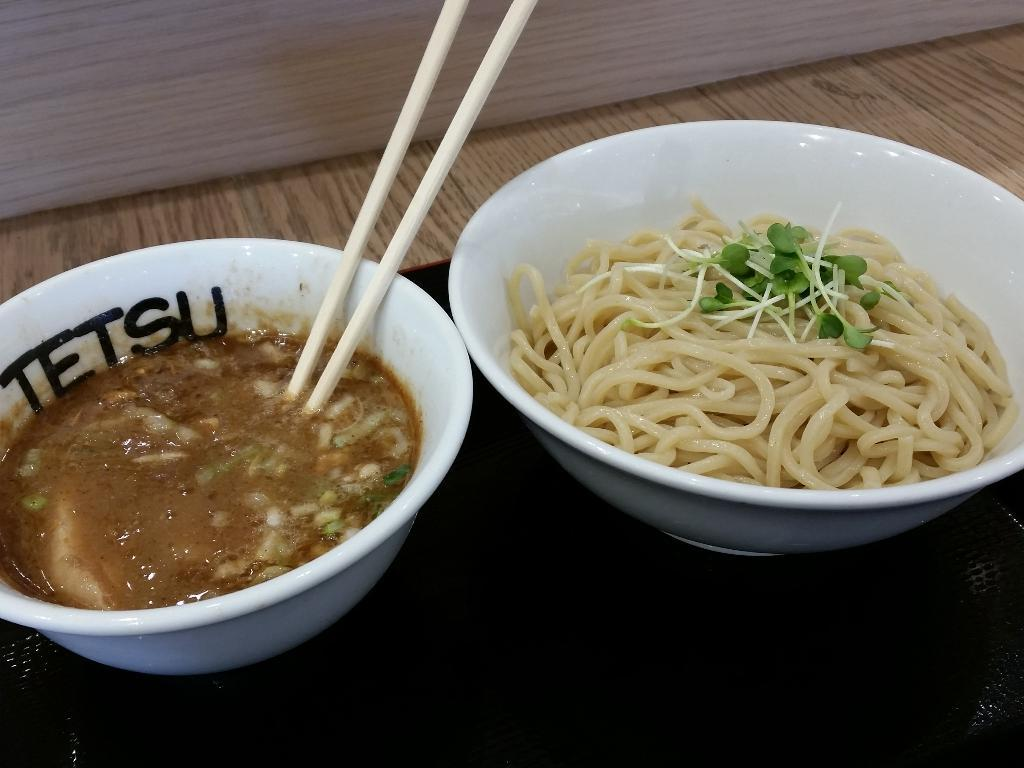What is in the bowl that is visible on the table in the image? There is a bowl with noodles on the table. Are there any other bowls with food on the table? Yes, there is another bowl with food is visible on the table. What utensils are present on the table for eating the food? There are two chopsticks on the table. What type of learning can be observed in the image? There is no learning activity depicted in the image; it shows a bowl of noodles, another bowl of food, and chopsticks on a table. Can you see any snails in the image? There are no snails present in the image. 